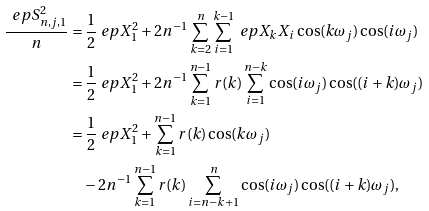<formula> <loc_0><loc_0><loc_500><loc_500>\frac { \ e p S ^ { 2 } _ { n , j , 1 } } { n } & = \frac { 1 } { 2 } \ e p X ^ { 2 } _ { 1 } + 2 n ^ { - 1 } \sum _ { k = 2 } ^ { n } \sum _ { i = 1 } ^ { k - 1 } \ e p X _ { k } X _ { i } \cos ( k \omega _ { j } ) \cos ( i \omega _ { j } ) \\ & = \frac { 1 } { 2 } \ e p X ^ { 2 } _ { 1 } + 2 n ^ { - 1 } \sum _ { k = 1 } ^ { n - 1 } r ( k ) \sum _ { i = 1 } ^ { n - k } \cos ( i \omega _ { j } ) \cos ( ( i + k ) \omega _ { j } ) \\ & = \frac { 1 } { 2 } \ e p X ^ { 2 } _ { 1 } + \sum _ { k = 1 } ^ { n - 1 } r ( k ) \cos ( k \omega _ { j } ) \\ & \quad - 2 n ^ { - 1 } \sum _ { k = 1 } ^ { n - 1 } r ( k ) \sum _ { i = n - k + 1 } ^ { n } \cos ( i \omega _ { j } ) \cos ( ( i + k ) \omega _ { j } ) ,</formula> 